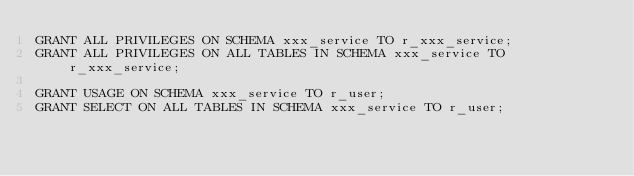Convert code to text. <code><loc_0><loc_0><loc_500><loc_500><_SQL_>GRANT ALL PRIVILEGES ON SCHEMA xxx_service TO r_xxx_service;
GRANT ALL PRIVILEGES ON ALL TABLES IN SCHEMA xxx_service TO r_xxx_service;

GRANT USAGE ON SCHEMA xxx_service TO r_user;
GRANT SELECT ON ALL TABLES IN SCHEMA xxx_service TO r_user;
</code> 